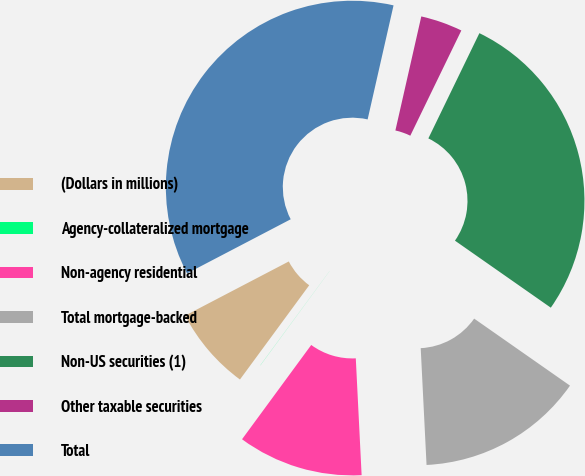<chart> <loc_0><loc_0><loc_500><loc_500><pie_chart><fcel>(Dollars in millions)<fcel>Agency-collateralized mortgage<fcel>Non-agency residential<fcel>Total mortgage-backed<fcel>Non-US securities (1)<fcel>Other taxable securities<fcel>Total<nl><fcel>7.25%<fcel>0.01%<fcel>10.87%<fcel>14.49%<fcel>27.52%<fcel>3.63%<fcel>36.21%<nl></chart> 